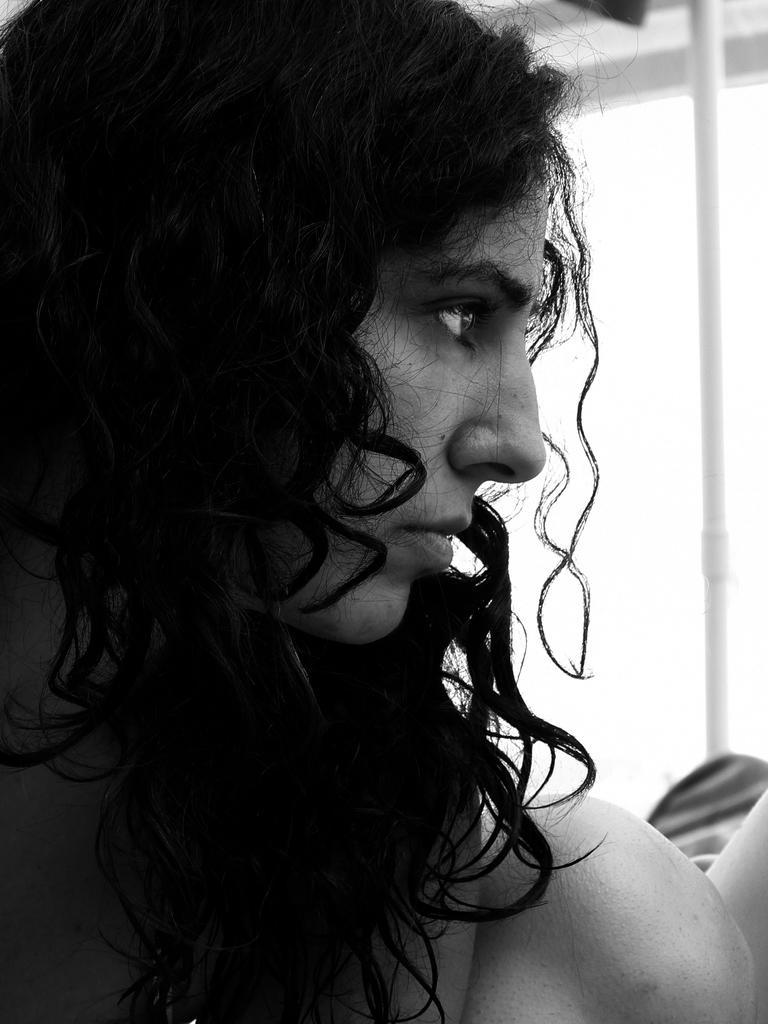Who is the main subject in the image? There is a woman in the image. What is the woman doing in the image? The woman is looking to the right. What is the color scheme of the image? The image is in black and white color. What type of vegetable is the woman holding in the image? There is no vegetable present in the image; the woman is not holding anything. 